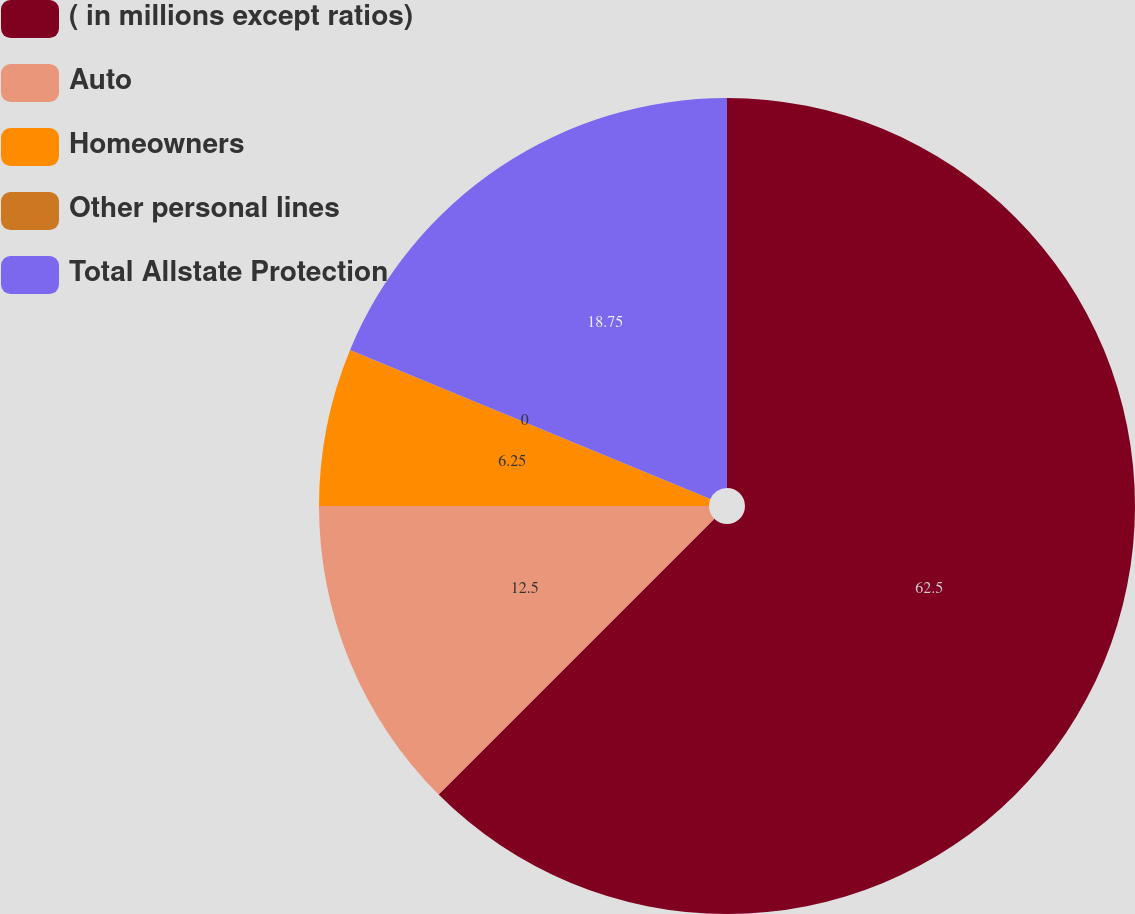Convert chart to OTSL. <chart><loc_0><loc_0><loc_500><loc_500><pie_chart><fcel>( in millions except ratios)<fcel>Auto<fcel>Homeowners<fcel>Other personal lines<fcel>Total Allstate Protection<nl><fcel>62.49%<fcel>12.5%<fcel>6.25%<fcel>0.0%<fcel>18.75%<nl></chart> 